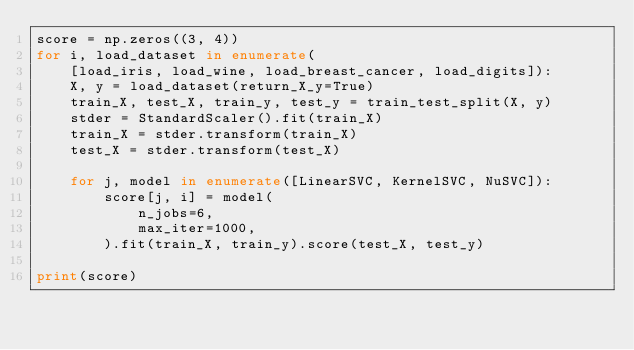Convert code to text. <code><loc_0><loc_0><loc_500><loc_500><_Python_>score = np.zeros((3, 4))
for i, load_dataset in enumerate(
    [load_iris, load_wine, load_breast_cancer, load_digits]):
    X, y = load_dataset(return_X_y=True)
    train_X, test_X, train_y, test_y = train_test_split(X, y)
    stder = StandardScaler().fit(train_X)
    train_X = stder.transform(train_X)
    test_X = stder.transform(test_X)

    for j, model in enumerate([LinearSVC, KernelSVC, NuSVC]):
        score[j, i] = model(
            n_jobs=6,
            max_iter=1000,
        ).fit(train_X, train_y).score(test_X, test_y)

print(score)</code> 